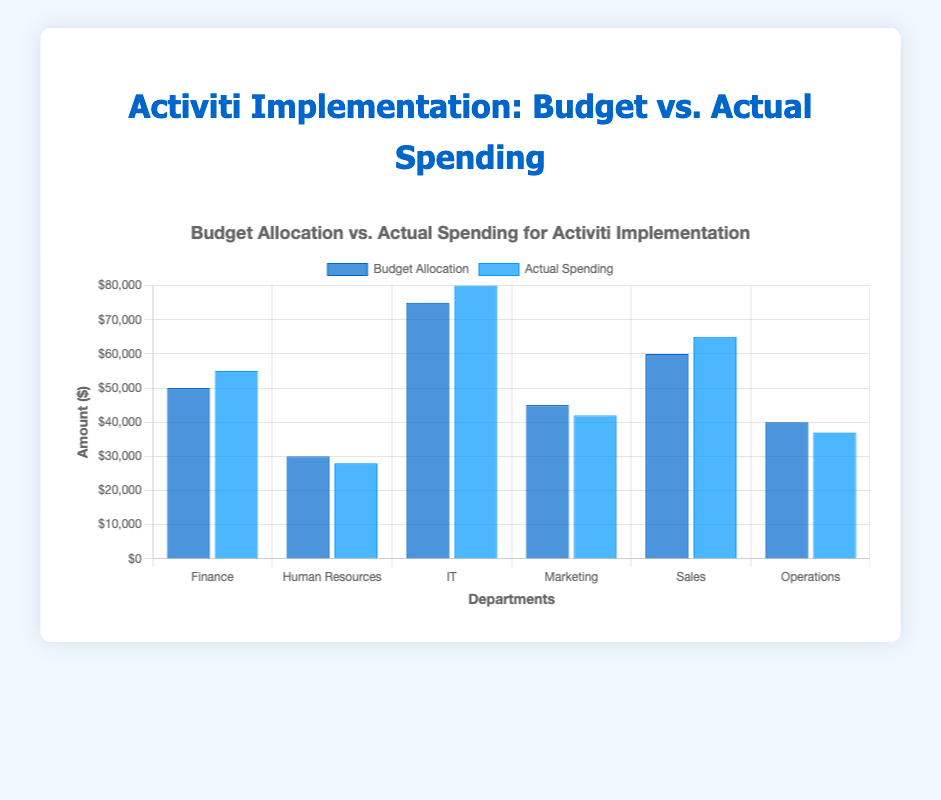Which department exceeded its budget by the highest amount? To determine which department exceeded its budget by the highest amount, compare the actual spending to the budget allocation for each department and find the largest positive difference. Finance: 55000 - 50000 = 5000, IT: 80000 - 75000 = 5000, Sales: 65000 - 60000 = 5000. All three departments exceeded their budget by $5000, which is the highest amount.
Answer: Finance, IT, Sales Which department spent the least compared to its budget? Compare the actual spending to the budget allocation for each department to identify which department had the smallest actual spending compared to its budget in absolute terms. Human Resources: 30000 - 28000 = 2000. Marketing: 45000 - 42000 = 3000. Operations: 40000 - 37000 = 3000. Human Resources spent $2000 less than its budget, the smallest difference.
Answer: Human Resources How much did the IT department overspend by? Calculate the difference between the actual spending and budget allocation for the IT department: actual spending (80000) - budget allocation (75000) = 5000.
Answer: 5000 Which departments stayed within their budget? Identify departments where actual spending is less than or equal to the budget allocation. Human Resources: 28000 < 30000. Marketing: 42000 < 45000. Operations: 37000 < 40000.
Answer: Human Resources, Marketing, Operations What is the total budget allocation for all departments? Sum the budget allocations of all departments: 50000 + 30000 + 75000 + 45000 + 60000 + 40000 = 300000.
Answer: 300000 What is the total actual spending for all departments? Sum the actual spending of all departments: 55000 + 28000 + 80000 + 42000 + 65000 + 37000 = 307000.
Answer: 307000 How much more was spent than budgeted for the Sales department? Calculate the difference between actual spending and budget allocation for the Sales department: actual spending (65000) - budget allocation (60000) = 5000.
Answer: 5000 Which department had the highest budget allocation? Compare the budget allocations of all departments to determine the highest value. The IT department has the highest budget allocation of 75000.
Answer: IT If the Operations department had spent $5000 more, would it have exceeded its budget? Add $5000 to the actual spending of the Operations department and compare with its budget allocation: 37000 + 5000 = 42000, which is still less than the budget allocation of 40000.
Answer: Yes What is the average actual spending per department? Sum the actual spending of all departments and divide by the number of departments: (55000 + 28000 + 80000 + 42000 + 65000 + 37000) / 6 = 307000 / 6 ≈ 51167.
Answer: 51167 